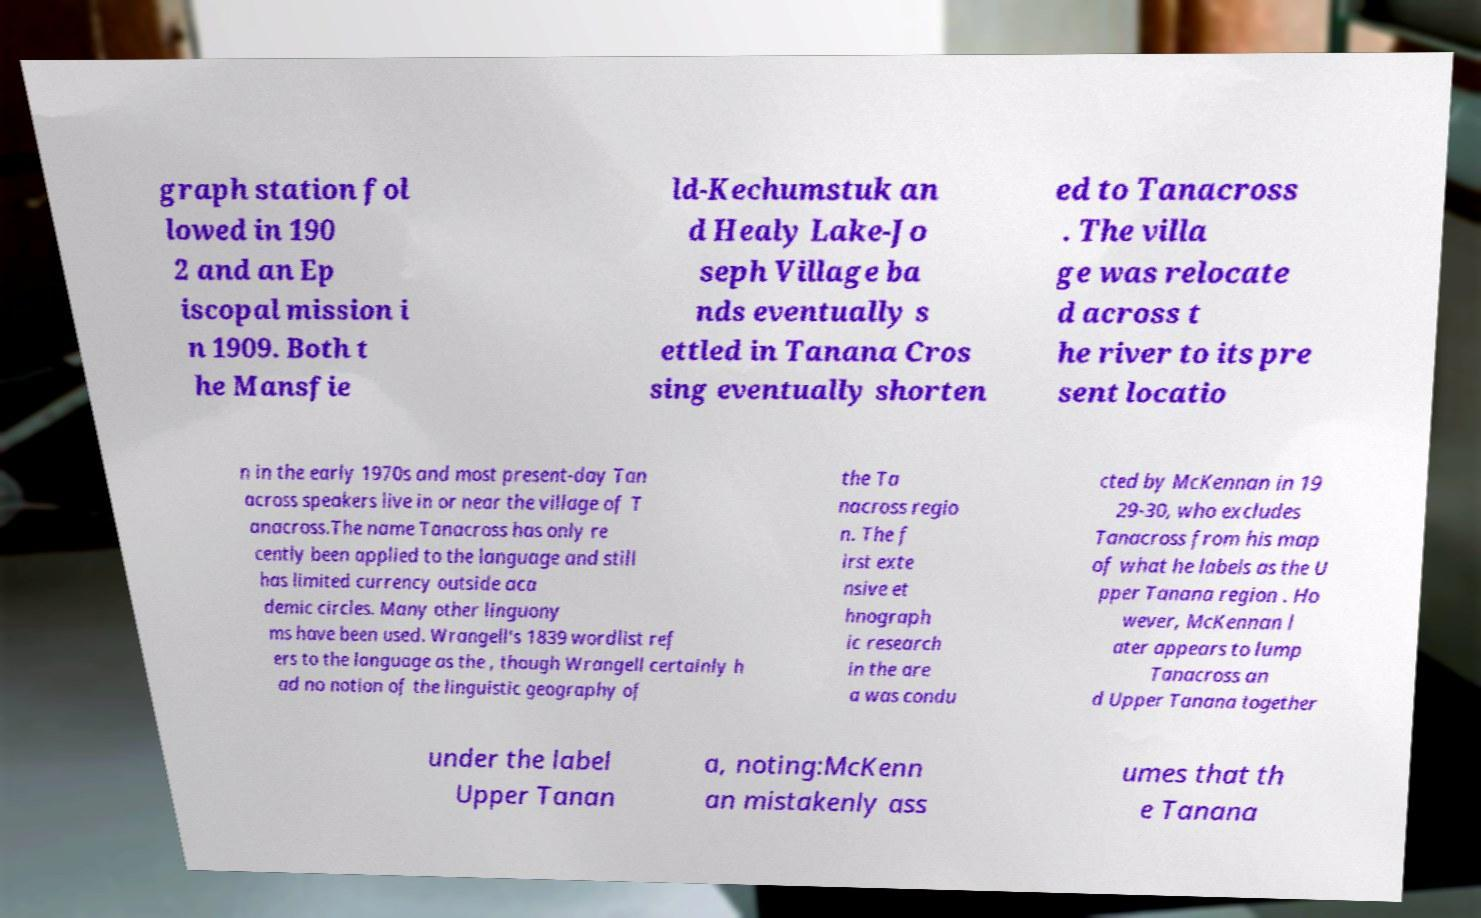Can you accurately transcribe the text from the provided image for me? graph station fol lowed in 190 2 and an Ep iscopal mission i n 1909. Both t he Mansfie ld-Kechumstuk an d Healy Lake-Jo seph Village ba nds eventually s ettled in Tanana Cros sing eventually shorten ed to Tanacross . The villa ge was relocate d across t he river to its pre sent locatio n in the early 1970s and most present-day Tan across speakers live in or near the village of T anacross.The name Tanacross has only re cently been applied to the language and still has limited currency outside aca demic circles. Many other linguony ms have been used. Wrangell's 1839 wordlist ref ers to the language as the , though Wrangell certainly h ad no notion of the linguistic geography of the Ta nacross regio n. The f irst exte nsive et hnograph ic research in the are a was condu cted by McKennan in 19 29-30, who excludes Tanacross from his map of what he labels as the U pper Tanana region . Ho wever, McKennan l ater appears to lump Tanacross an d Upper Tanana together under the label Upper Tanan a, noting:McKenn an mistakenly ass umes that th e Tanana 